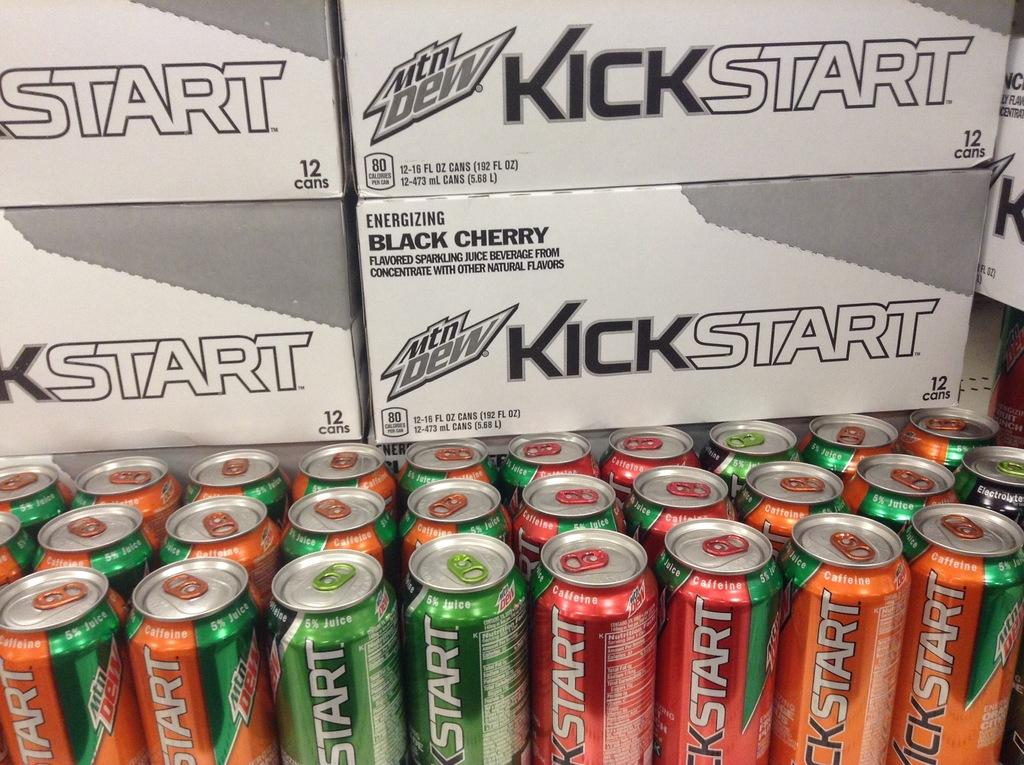Provide a one-sentence caption for the provided image. A pallet of Kickstart energy drinks made by Mountain Dew. 